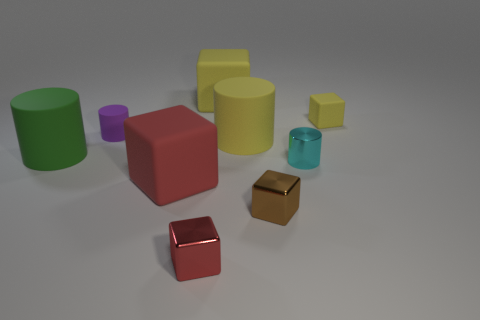Is there a big brown metallic thing of the same shape as the cyan object?
Offer a terse response. No. What number of brown objects are either small rubber cylinders or metallic spheres?
Offer a very short reply. 0. Is there a yellow rubber cube that has the same size as the green rubber thing?
Your response must be concise. Yes. What number of rubber cylinders are there?
Your answer should be very brief. 3. How many small objects are either matte cubes or gray cubes?
Your response must be concise. 1. There is a big matte cylinder in front of the big cylinder to the right of the big rubber cylinder that is to the left of the small red metallic thing; what color is it?
Make the answer very short. Green. What number of other things are there of the same color as the tiny shiny cylinder?
Your response must be concise. 0. What number of metal objects are big green objects or cyan things?
Your answer should be compact. 1. Do the small rubber thing on the right side of the small cyan metal cylinder and the big matte cube that is behind the small purple object have the same color?
Provide a succinct answer. Yes. There is a red rubber object that is the same shape as the tiny brown thing; what is its size?
Your response must be concise. Large. 